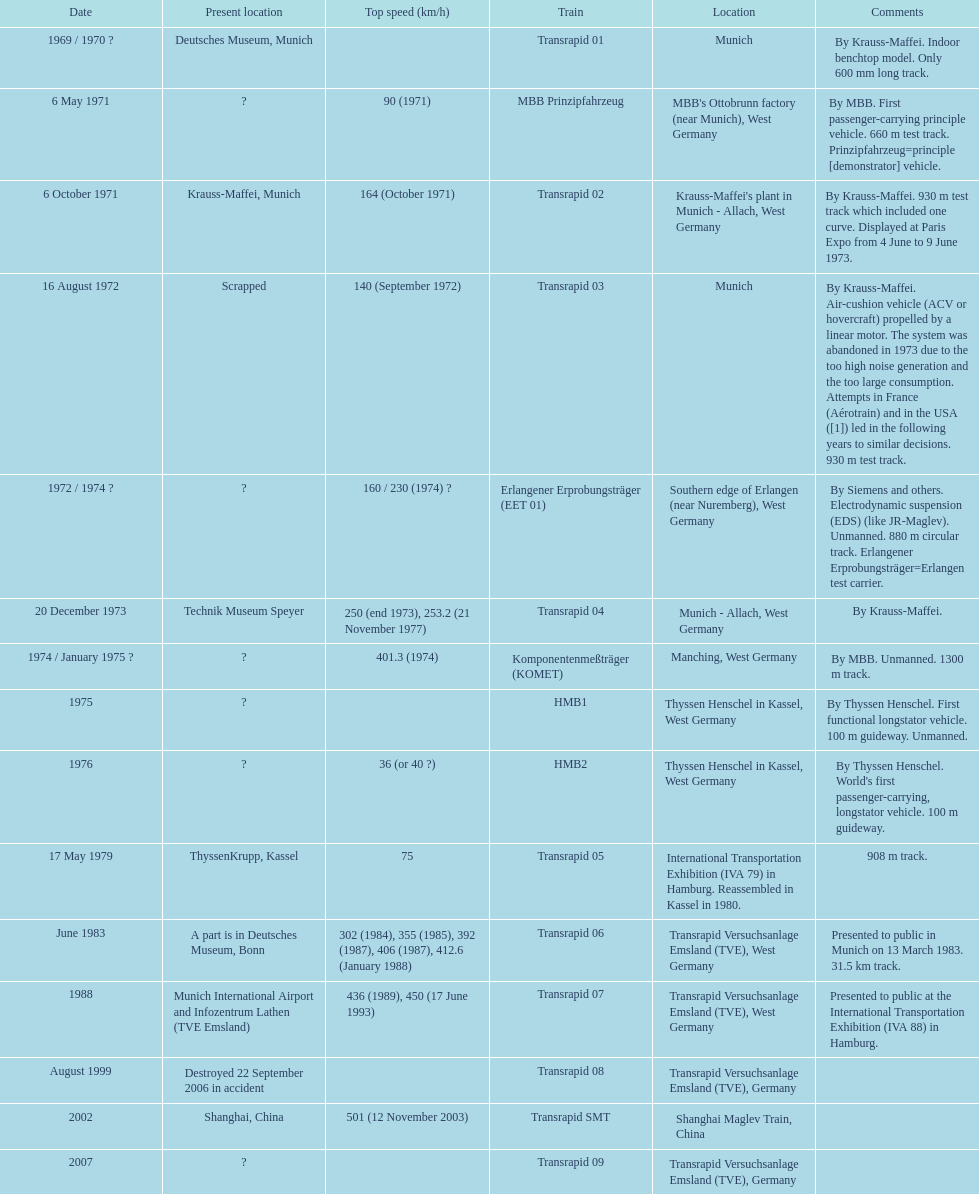How many trains listed have the same speed as the hmb2? 0. 